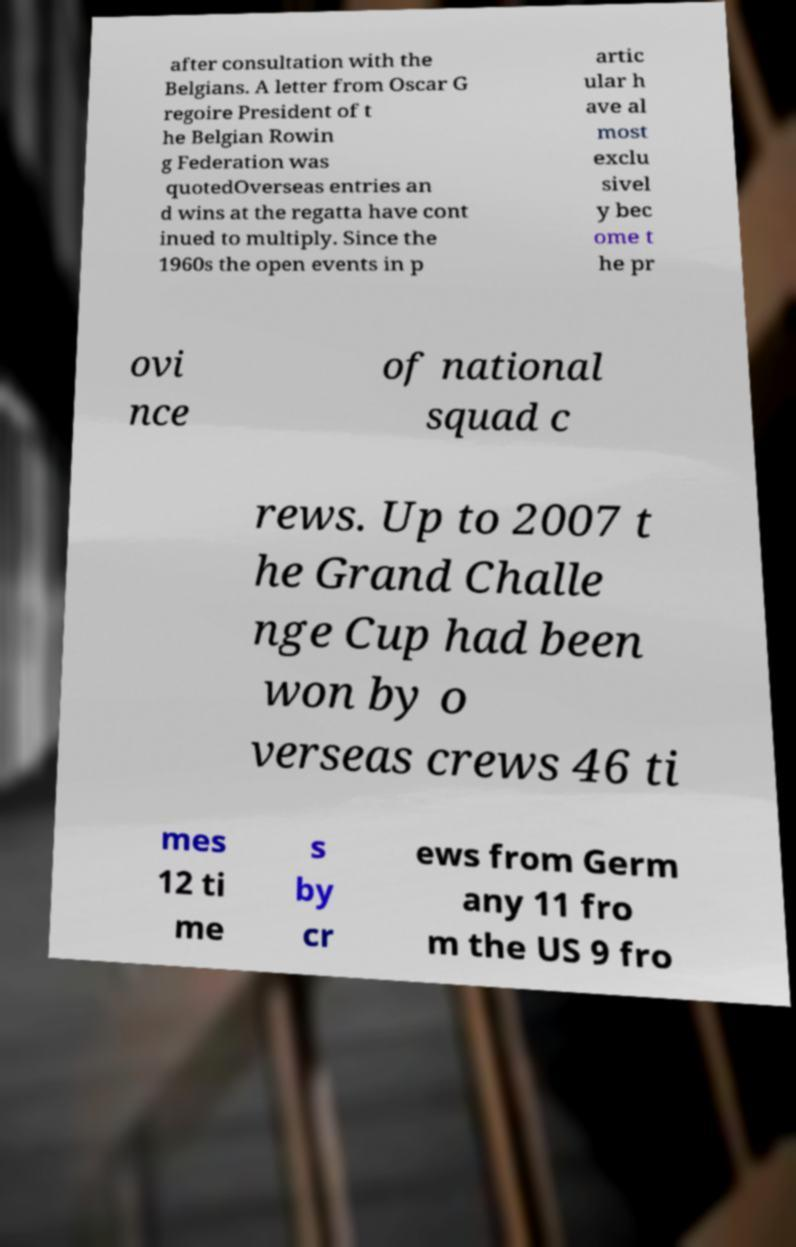What messages or text are displayed in this image? I need them in a readable, typed format. after consultation with the Belgians. A letter from Oscar G regoire President of t he Belgian Rowin g Federation was quotedOverseas entries an d wins at the regatta have cont inued to multiply. Since the 1960s the open events in p artic ular h ave al most exclu sivel y bec ome t he pr ovi nce of national squad c rews. Up to 2007 t he Grand Challe nge Cup had been won by o verseas crews 46 ti mes 12 ti me s by cr ews from Germ any 11 fro m the US 9 fro 